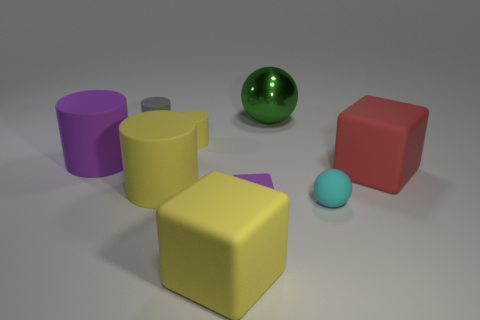Subtract 1 cylinders. How many cylinders are left? 3 Add 1 big yellow objects. How many objects exist? 10 Subtract all balls. How many objects are left? 7 Add 8 tiny purple matte things. How many tiny purple matte things exist? 9 Subtract 1 red cubes. How many objects are left? 8 Subtract all yellow cylinders. Subtract all big purple things. How many objects are left? 6 Add 5 purple matte cylinders. How many purple matte cylinders are left? 6 